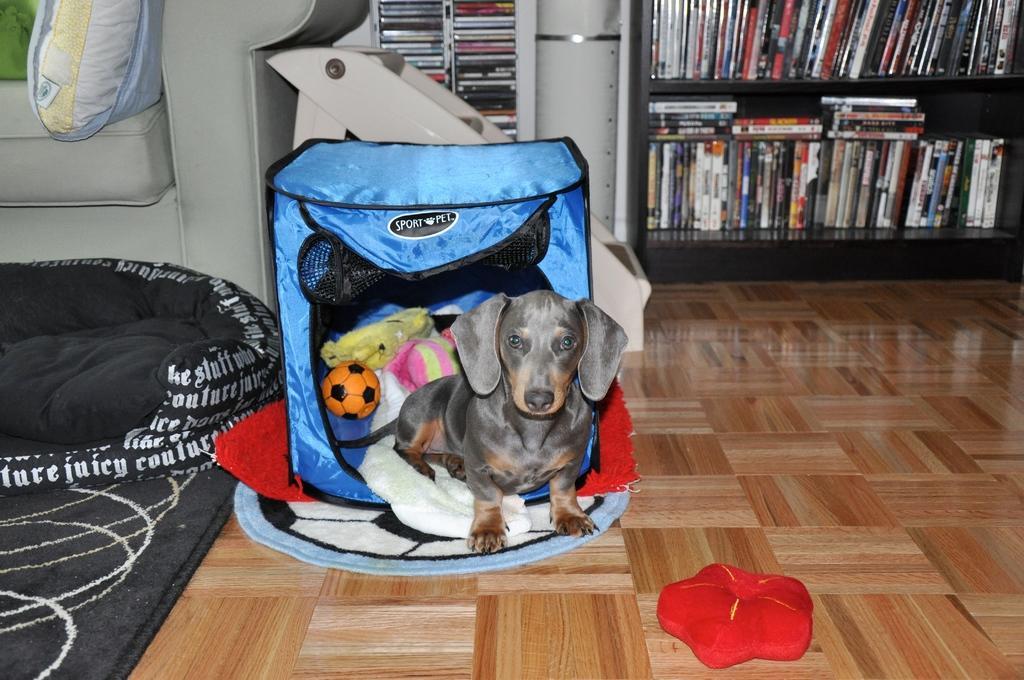Please provide a concise description of this image. In this picture I can see a black color dog is sitting in a blue color object. Here I can see a ball and other objects in it. In the background I can see a shelf which has books. On the left side of the image I can see a white color sofa which has a cushion on it. 